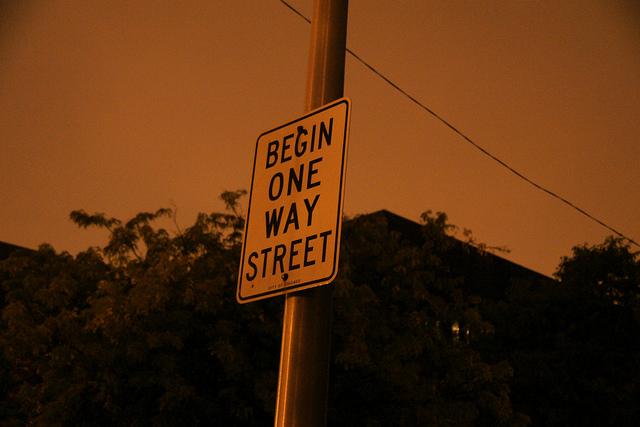Are one way signs facing the same direction?
Give a very brief answer. Yes. Is the name of this street one used by several entities?
Be succinct. Yes. Is it a sunny day?
Be succinct. No. What is the sign saying?
Be succinct. Begin one way street. Is the sign bolted into the poll?
Concise answer only. Yes. Is it night time?
Keep it brief. Yes. What type of utility pole is pictured?
Concise answer only. Metal. What color is the sky?
Answer briefly. Orange. What time of day is it?
Quick response, please. Evening. What color is the sky in this scene?
Keep it brief. Orange. Is it black and white?
Keep it brief. Yes. Are bicycles allowed?
Short answer required. Yes. What does the white sign read?
Concise answer only. Begin one way street. How many one way signs?
Give a very brief answer. 1. Is the sign in English?
Give a very brief answer. Yes. Is there a stop sign in the picture?
Be succinct. No. What is the color of the sky?
Quick response, please. Orange. What color is the sign?
Be succinct. White. What does the sign say?
Quick response, please. Begin one way street. What color is the writing on the sign?
Answer briefly. Black. 